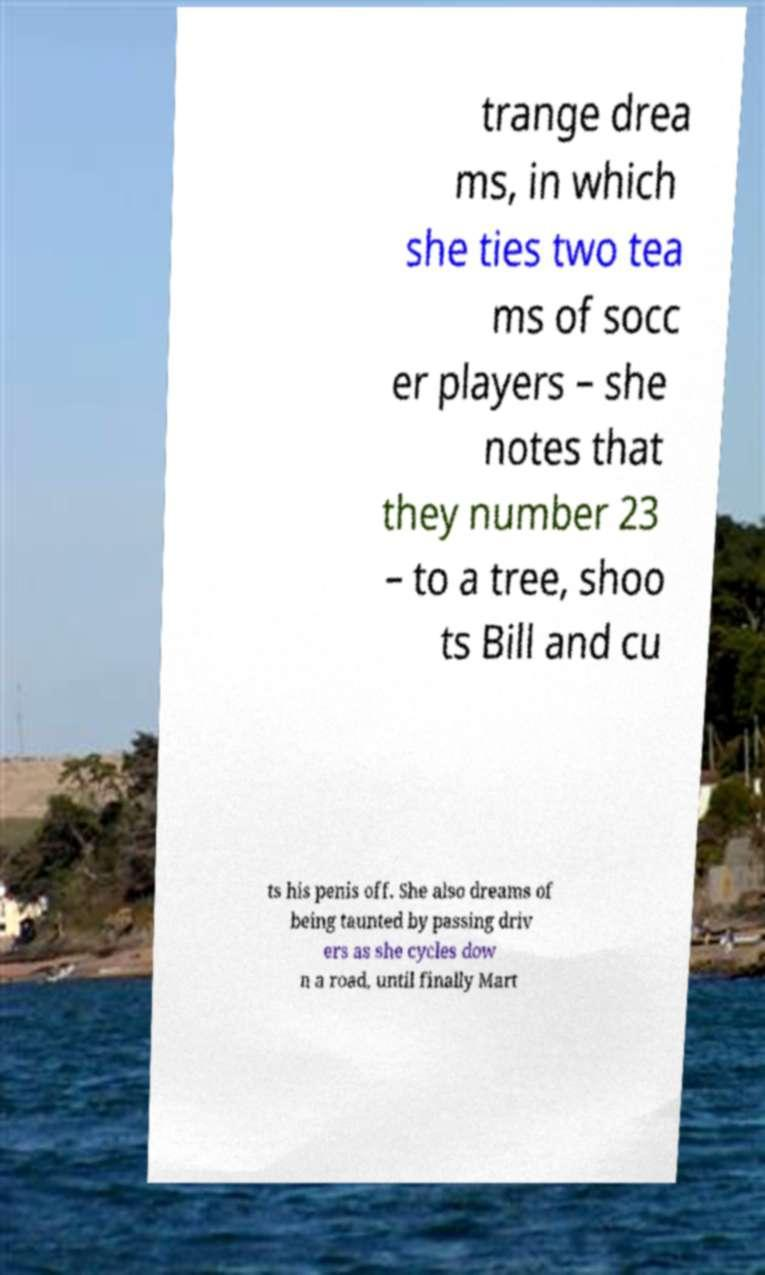Please identify and transcribe the text found in this image. trange drea ms, in which she ties two tea ms of socc er players – she notes that they number 23 – to a tree, shoo ts Bill and cu ts his penis off. She also dreams of being taunted by passing driv ers as she cycles dow n a road, until finally Mart 